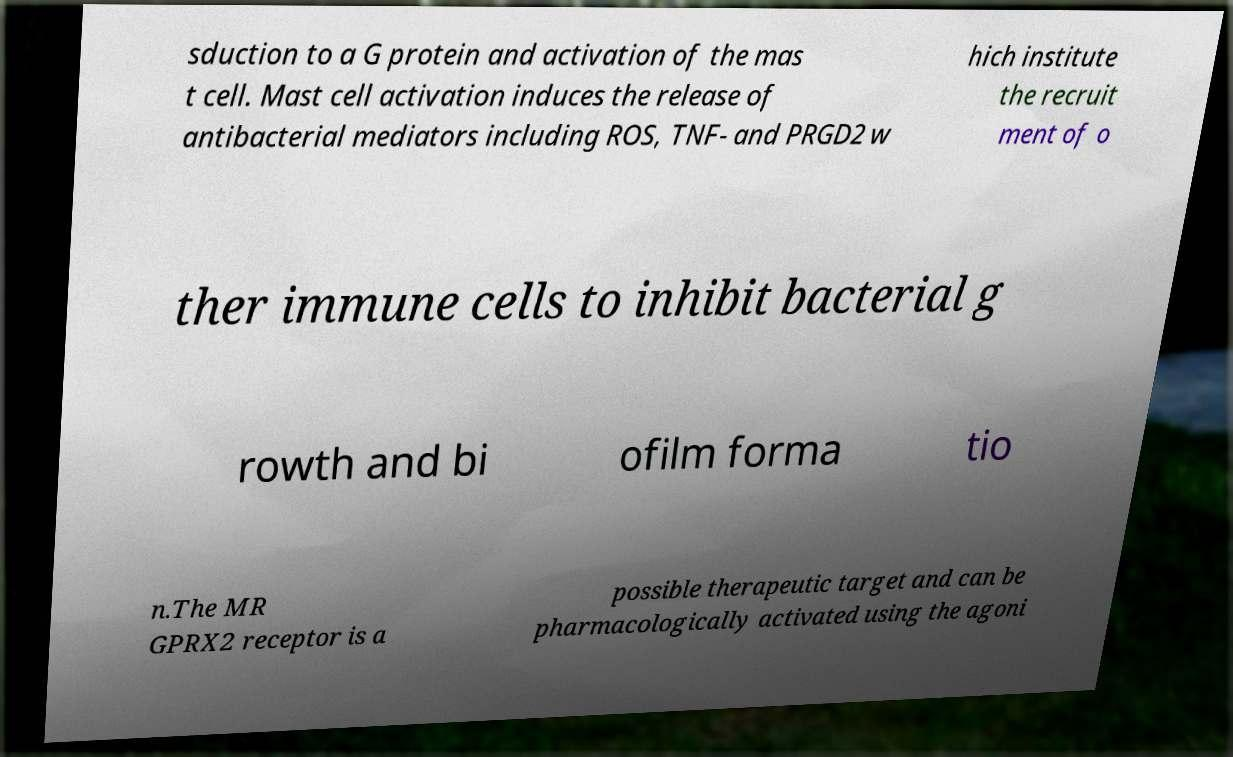What messages or text are displayed in this image? I need them in a readable, typed format. sduction to a G protein and activation of the mas t cell. Mast cell activation induces the release of antibacterial mediators including ROS, TNF- and PRGD2 w hich institute the recruit ment of o ther immune cells to inhibit bacterial g rowth and bi ofilm forma tio n.The MR GPRX2 receptor is a possible therapeutic target and can be pharmacologically activated using the agoni 